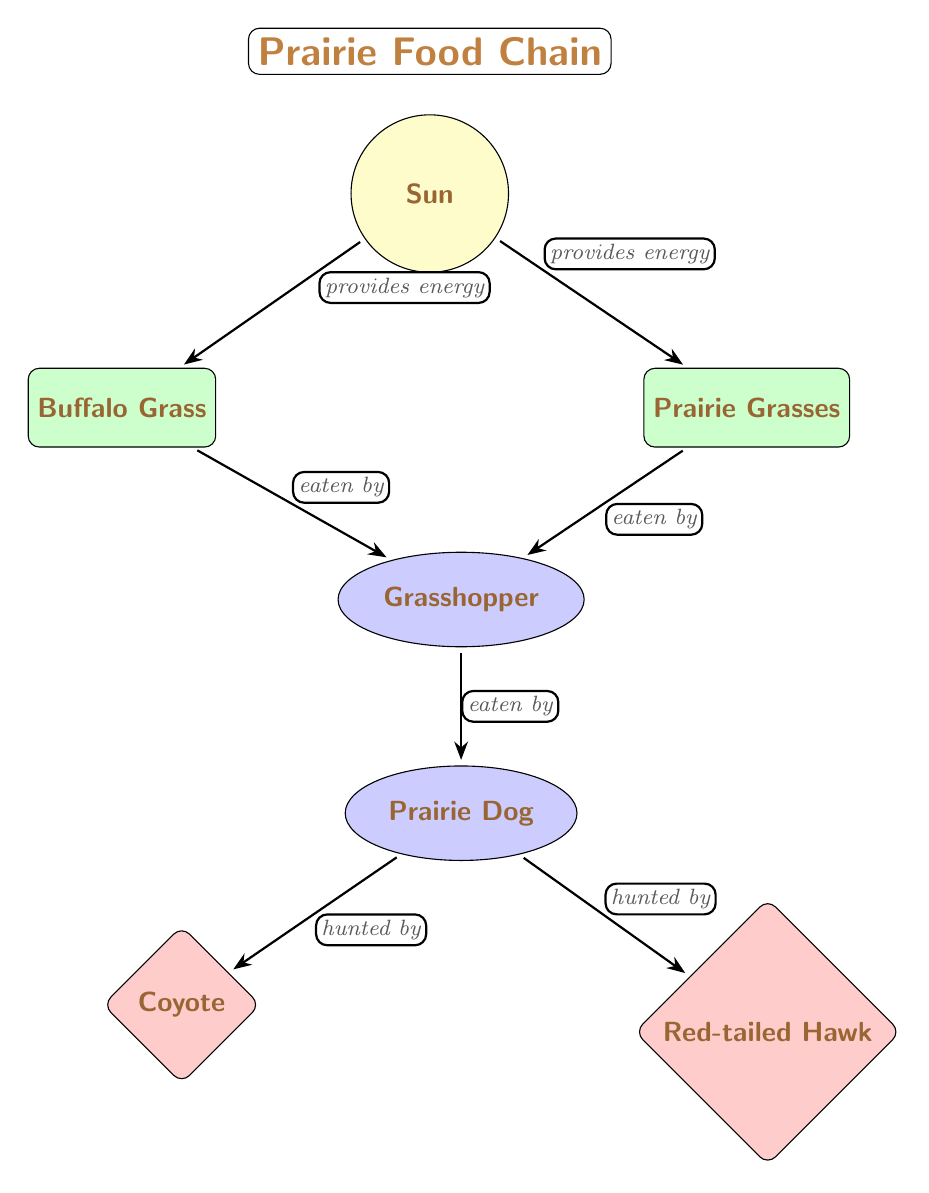What provides energy to the Buffalo Grass? According to the diagram, the Sun is directly linked to the Buffalo Grass by an edge labeled "provides energy." This indicates that the Sun is the source of energy for this plant.
Answer: Sun How many types of plants are shown in the diagram? The diagram displays two types of plants: Buffalo Grass and Prairie Grasses. To answer this, we count the rectangular nodes that represent plants in the diagram.
Answer: 2 Who is the primary predator of the Prairie Dog? The diagram indicates that the Coyote and the Red-tailed Hawk are predators of the Prairie Dog, but since the question asks for the primary predator, the Coyote is usually considered the main predator in such environments. Thus, we look for the predator node that connects specifically to the Prairie Dog.
Answer: Coyote What relationship does the Grasshopper have with the Prairie Dog? The relationship depicted in the diagram shows that the Grasshopper is "eaten by" the Prairie Dog. This is identified by the directed edge connecting the Grasshopper to the Prairie Dog with that label.
Answer: eaten by How many total edges are in the food chain diagram? By examining the diagram, we can count the edges connecting the nodes: there are a total of six edges connecting the Sun to the plants, plants to the Grasshopper, Grasshopper to the Prairie Dog, and the Prairie Dog to both of its predators. We add them up to get the total.
Answer: 6 Which animal is at the top of the food chain in the prairie ecosystem represented here? In the diagram, the top position in the food chain is represented by the Coyote and the Red-tailed Hawk, as they are the predators of the Prairie Dog. We identify this by looking for the predator nodes that have edges extending from the Prairie Dog.
Answer: Coyote and Red-tailed Hawk What energy source supports both types of plants in the diagram? The energy source that supports both Buffalo Grass and Prairie Grasses is the Sun, as indicated by the direct edges labeled "provides energy" connecting the Sun to each of these plants.
Answer: Sun What do Prairie Dogs and Grasshoppers have in common? Both Prairie Dogs and Grasshoppers are linked in the food chain as they are both essential components of the ecosystem. Specifically, they share a relationship where Grasshoppers are food for Prairie Dogs, making them both important in the energy transfer in the food chain.
Answer: eaten by 